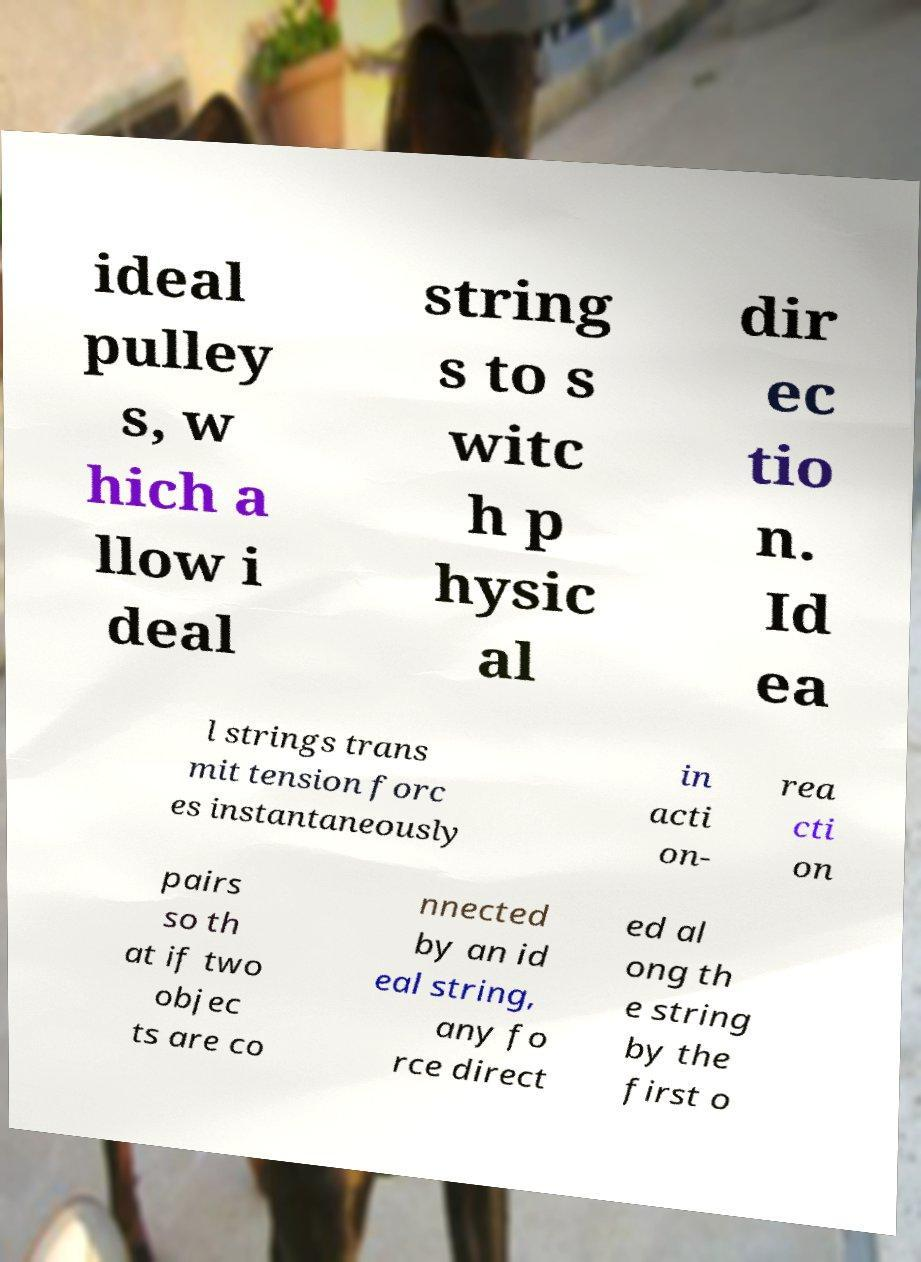Please identify and transcribe the text found in this image. ideal pulley s, w hich a llow i deal string s to s witc h p hysic al dir ec tio n. Id ea l strings trans mit tension forc es instantaneously in acti on- rea cti on pairs so th at if two objec ts are co nnected by an id eal string, any fo rce direct ed al ong th e string by the first o 